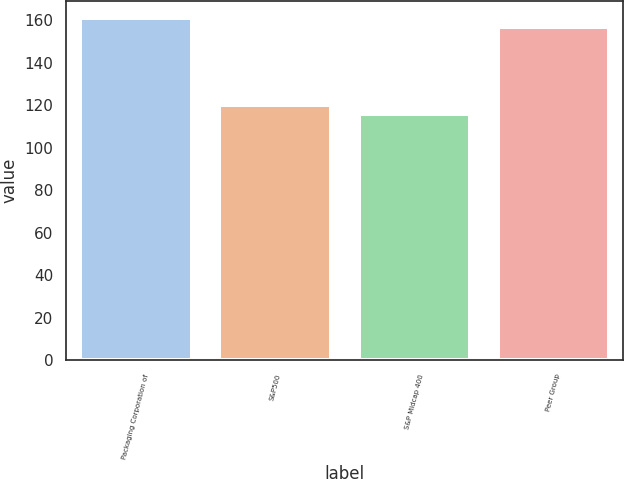<chart> <loc_0><loc_0><loc_500><loc_500><bar_chart><fcel>Packaging Corporation of<fcel>S&P500<fcel>S&P Midcap 400<fcel>Peer Group<nl><fcel>160.93<fcel>120.1<fcel>115.84<fcel>156.67<nl></chart> 